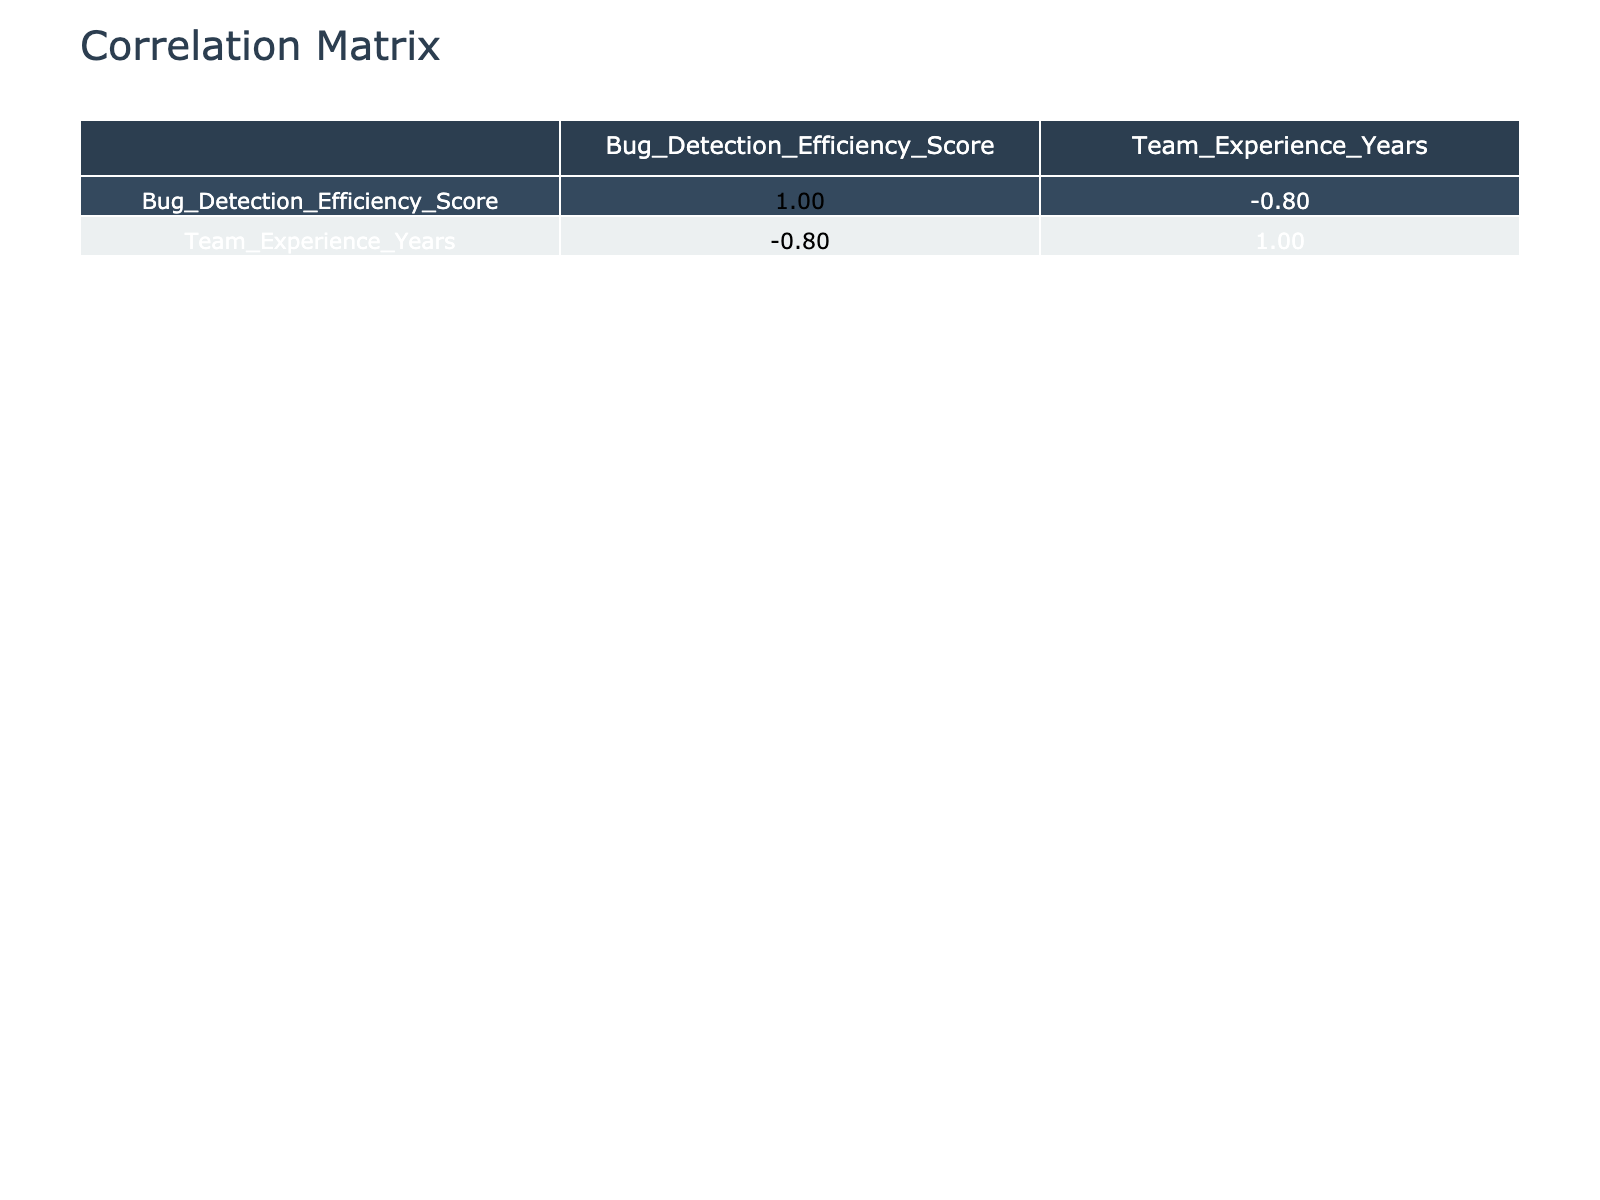What is the Bug Detection Efficiency Score for Selenium? From the table, I can locate the row for Selenium, which shows the Bug Detection Efficiency Score directly.
Answer: 85 Which Testing Framework has the highest Bug Detection Efficiency Score? By looking through each score, I see that Playwright has the highest score of 91.
Answer: Playwright Is the Bug Detection Efficiency Score for JUnit greater than or equal to 80? The score for JUnit is 78, which is less than 80. Therefore, the statement is false.
Answer: No What is the average Bug Detection Efficiency Score for frameworks that use JavaScript? The scores for JavaScript frameworks are 85 (Selenium), 90 (Cypress), 82 (Mocha), 91 (Playwright), and 83 (QUnit). The total is 85 + 90 + 82 + 91 + 83 = 431. Dividing by 5 gives an average of 431 / 5 = 86.2.
Answer: 86.2 Is there a correlation between Complexity Level and Bug Detection Efficiency? To determine this, I compare the scores across different levels of complexity. High complexity has scores of 85 (Selenium) and 80 (TestNG), which averages to 82.5, while medium has 90 (Cypress), 82 (Mocha), and 91 (Playwright), averaging to 87.67. Low complexity has one score of 88 (pytest). This observation suggests there is a potential correlation, but additional statistical analysis would be required for a definitive conclusion.
Answer: Yes Which language/framework combination has the lowest Bug Detection Efficiency Score? Among the provided data, Robot Framework with Python has the lowest score of 76.
Answer: Robot Framework, Python Are all frameworks with a complexity level of Medium rated higher than 80? The scores for Medium complexity frameworks are 90 (Cypress), 82 (Mocha), and 88 (pytest). The lowest among these is 82, which is greater than 80. Therefore, the statement is true.
Answer: Yes What is the sum of the Bug Detection Efficiency Scores for frameworks with a Team Experience of 3 years? The frameworks with 3 years of experience are Selenium (85), Mocha (82), and QUnit (83). The sum is 85 + 82 + 83 = 250.
Answer: 250 Does a higher Team Experience correlate with higher Bug Detection Efficiency? To assess this, I compare the scores and experiences. For instance, TestNG (6 years) has a score of 80, while Cypress (2 years) has a score of 90. It's inconsistent, showing that higher experience doesn't always imply higher efficiency.
Answer: No 